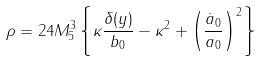Convert formula to latex. <formula><loc_0><loc_0><loc_500><loc_500>\rho = 2 4 M _ { 5 } ^ { 3 } \left \{ \kappa \frac { \delta ( y ) } { b _ { 0 } } - \kappa ^ { 2 } + \left ( \frac { \dot { a } _ { 0 } } { a _ { 0 } } \right ) ^ { 2 } \right \}</formula> 